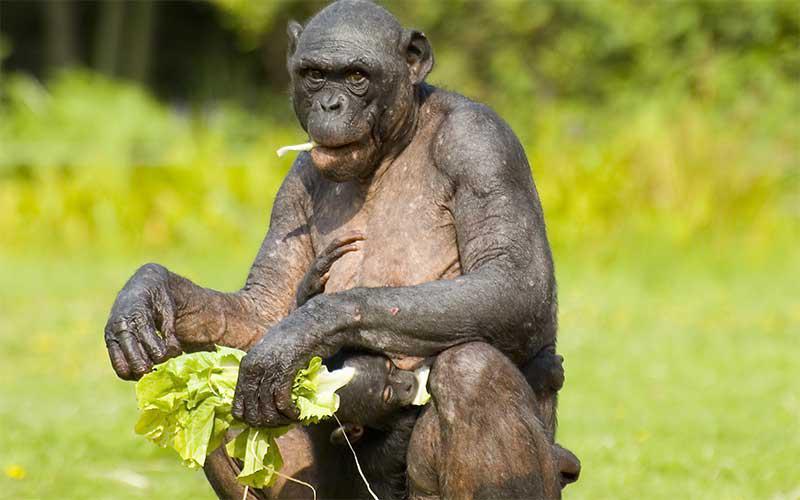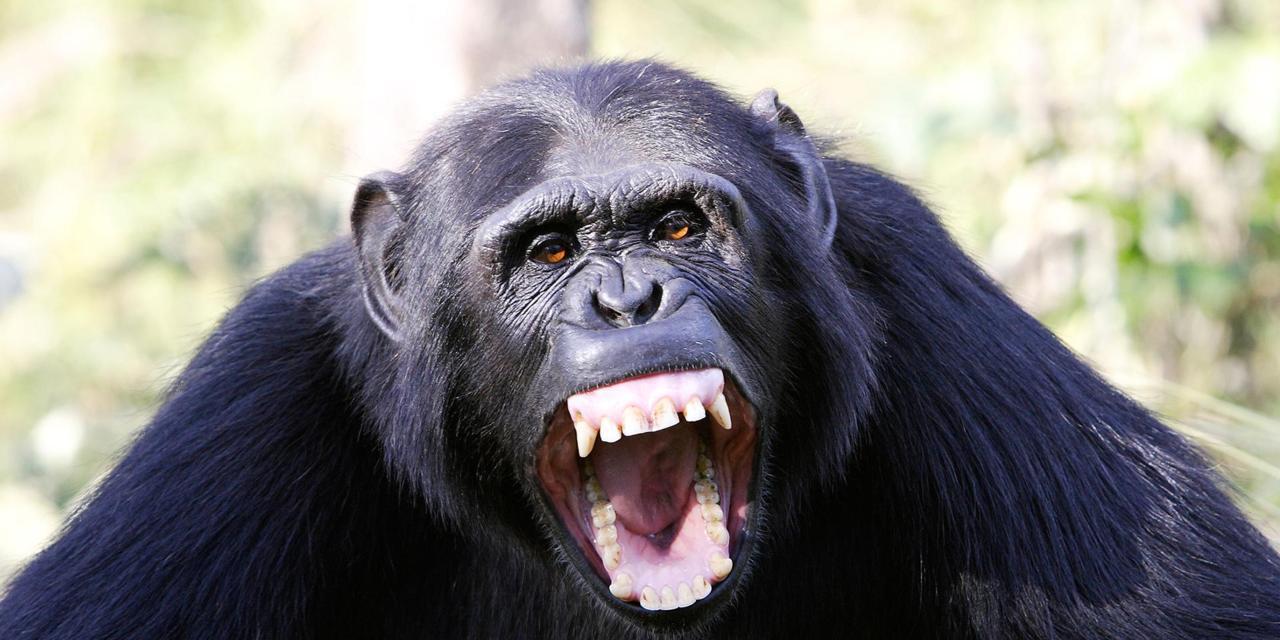The first image is the image on the left, the second image is the image on the right. Evaluate the accuracy of this statement regarding the images: "There is exactly one animal in the image on the right.". Is it true? Answer yes or no. Yes. The first image is the image on the left, the second image is the image on the right. Analyze the images presented: Is the assertion "One image shows two chimpanzees sitting in the grass together." valid? Answer yes or no. No. 